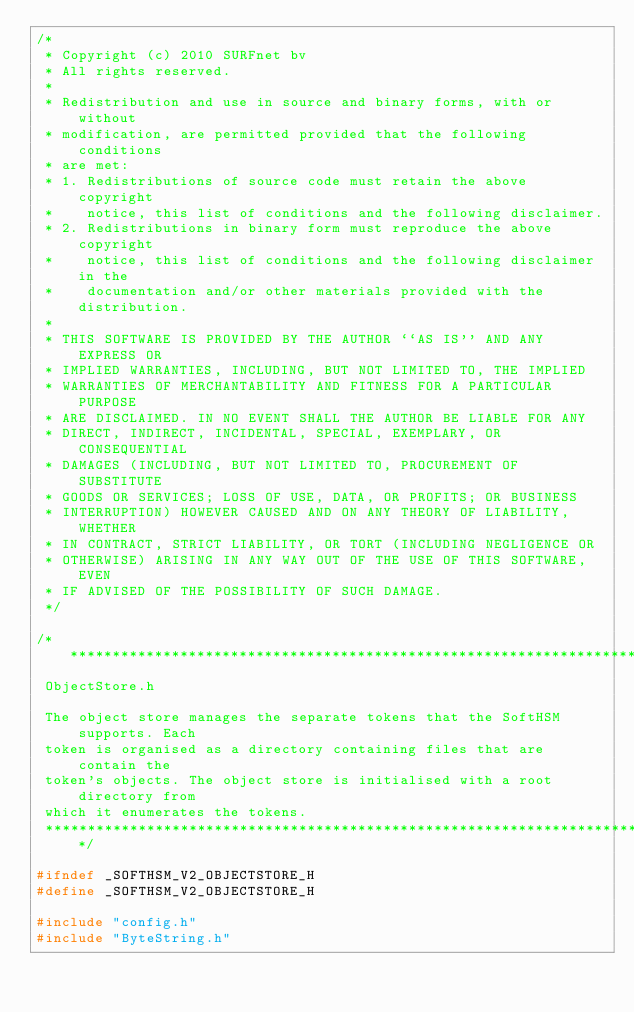Convert code to text. <code><loc_0><loc_0><loc_500><loc_500><_C_>/*
 * Copyright (c) 2010 SURFnet bv
 * All rights reserved.
 *
 * Redistribution and use in source and binary forms, with or without
 * modification, are permitted provided that the following conditions
 * are met:
 * 1. Redistributions of source code must retain the above copyright
 *    notice, this list of conditions and the following disclaimer.
 * 2. Redistributions in binary form must reproduce the above copyright
 *    notice, this list of conditions and the following disclaimer in the
 *    documentation and/or other materials provided with the distribution.
 *
 * THIS SOFTWARE IS PROVIDED BY THE AUTHOR ``AS IS'' AND ANY EXPRESS OR
 * IMPLIED WARRANTIES, INCLUDING, BUT NOT LIMITED TO, THE IMPLIED
 * WARRANTIES OF MERCHANTABILITY AND FITNESS FOR A PARTICULAR PURPOSE
 * ARE DISCLAIMED. IN NO EVENT SHALL THE AUTHOR BE LIABLE FOR ANY
 * DIRECT, INDIRECT, INCIDENTAL, SPECIAL, EXEMPLARY, OR CONSEQUENTIAL
 * DAMAGES (INCLUDING, BUT NOT LIMITED TO, PROCUREMENT OF SUBSTITUTE
 * GOODS OR SERVICES; LOSS OF USE, DATA, OR PROFITS; OR BUSINESS
 * INTERRUPTION) HOWEVER CAUSED AND ON ANY THEORY OF LIABILITY, WHETHER
 * IN CONTRACT, STRICT LIABILITY, OR TORT (INCLUDING NEGLIGENCE OR
 * OTHERWISE) ARISING IN ANY WAY OUT OF THE USE OF THIS SOFTWARE, EVEN
 * IF ADVISED OF THE POSSIBILITY OF SUCH DAMAGE.
 */

/*****************************************************************************
 ObjectStore.h

 The object store manages the separate tokens that the SoftHSM supports. Each
 token is organised as a directory containing files that are contain the
 token's objects. The object store is initialised with a root directory from
 which it enumerates the tokens.
 *****************************************************************************/

#ifndef _SOFTHSM_V2_OBJECTSTORE_H
#define _SOFTHSM_V2_OBJECTSTORE_H

#include "config.h"
#include "ByteString.h"</code> 